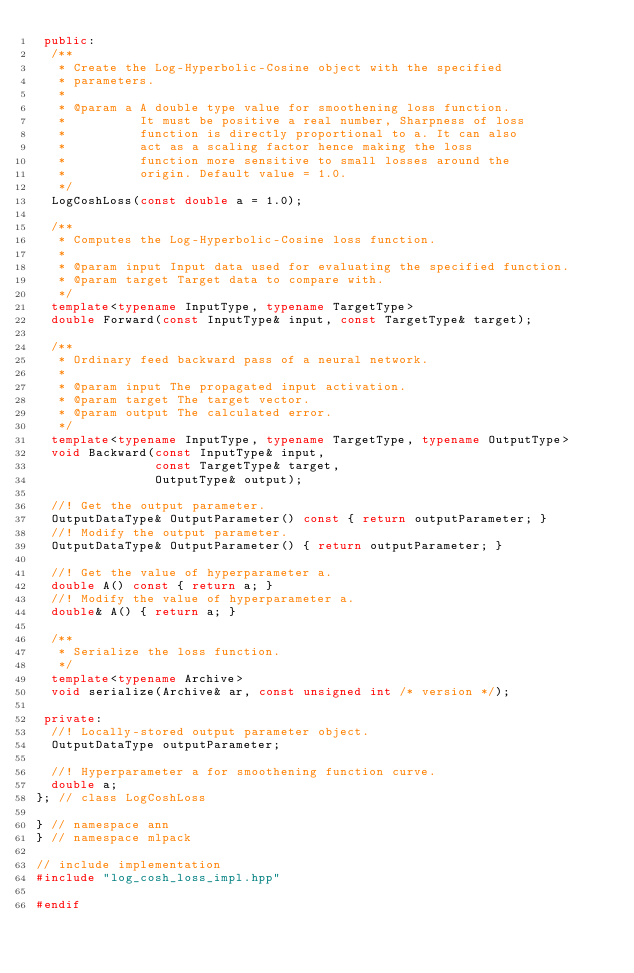<code> <loc_0><loc_0><loc_500><loc_500><_C++_> public:
  /**
   * Create the Log-Hyperbolic-Cosine object with the specified
   * parameters.
   *
   * @param a A double type value for smoothening loss function.
   *          It must be positive a real number, Sharpness of loss
   *          function is directly proportional to a. It can also
   *          act as a scaling factor hence making the loss
   *          function more sensitive to small losses around the
   *          origin. Default value = 1.0.
   */
  LogCoshLoss(const double a = 1.0);

  /**
   * Computes the Log-Hyperbolic-Cosine loss function.
   *
   * @param input Input data used for evaluating the specified function.
   * @param target Target data to compare with.
   */
  template<typename InputType, typename TargetType>
  double Forward(const InputType& input, const TargetType& target);

  /**
   * Ordinary feed backward pass of a neural network.
   *
   * @param input The propagated input activation.
   * @param target The target vector.
   * @param output The calculated error.
   */
  template<typename InputType, typename TargetType, typename OutputType>
  void Backward(const InputType& input,
                const TargetType& target,
                OutputType& output);

  //! Get the output parameter.
  OutputDataType& OutputParameter() const { return outputParameter; }
  //! Modify the output parameter.
  OutputDataType& OutputParameter() { return outputParameter; }

  //! Get the value of hyperparameter a.
  double A() const { return a; }
  //! Modify the value of hyperparameter a.
  double& A() { return a; }

  /**
   * Serialize the loss function.
   */
  template<typename Archive>
  void serialize(Archive& ar, const unsigned int /* version */);

 private:
  //! Locally-stored output parameter object.
  OutputDataType outputParameter;

  //! Hyperparameter a for smoothening function curve.
  double a;
}; // class LogCoshLoss

} // namespace ann
} // namespace mlpack

// include implementation
#include "log_cosh_loss_impl.hpp"

#endif
</code> 